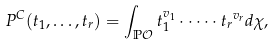<formula> <loc_0><loc_0><loc_500><loc_500>P ^ { C } ( t _ { 1 } , \dots , t _ { r } ) = \int _ { \mathbb { P } \mathcal { O } } t _ { 1 } ^ { v _ { 1 } } \cdot \dots \cdot { t _ { r } } ^ { v _ { r } } d \chi ,</formula> 